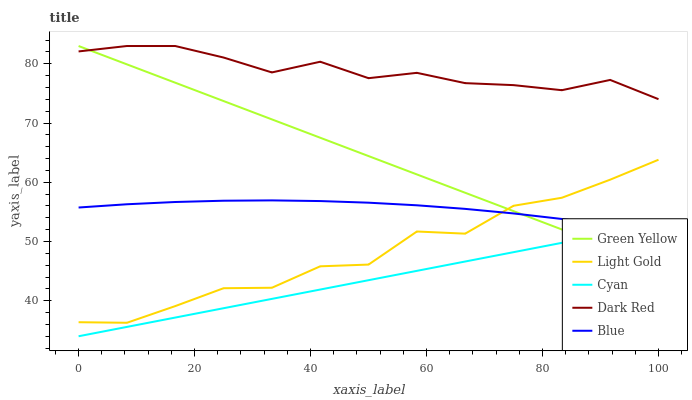Does Green Yellow have the minimum area under the curve?
Answer yes or no. No. Does Green Yellow have the maximum area under the curve?
Answer yes or no. No. Is Green Yellow the smoothest?
Answer yes or no. No. Is Green Yellow the roughest?
Answer yes or no. No. Does Green Yellow have the lowest value?
Answer yes or no. No. Does Cyan have the highest value?
Answer yes or no. No. Is Cyan less than Dark Red?
Answer yes or no. Yes. Is Dark Red greater than Blue?
Answer yes or no. Yes. Does Cyan intersect Dark Red?
Answer yes or no. No. 